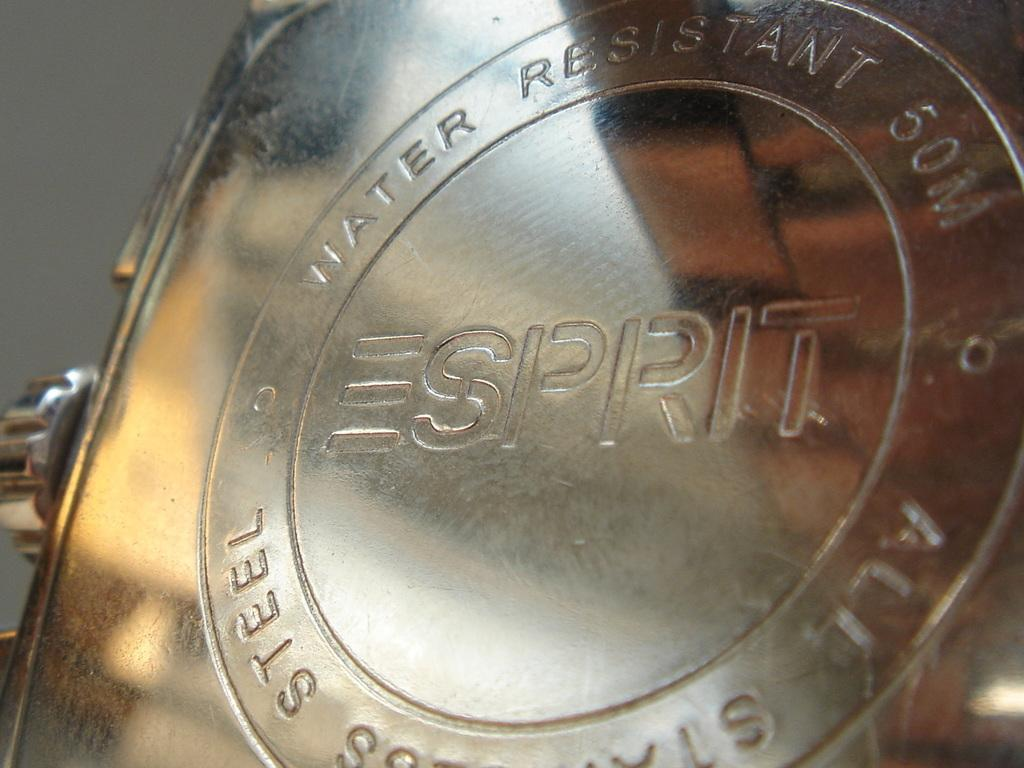<image>
Render a clear and concise summary of the photo. The rear of an Espirit watch is silver and has words that says it is water resistant up to fifty metres. 